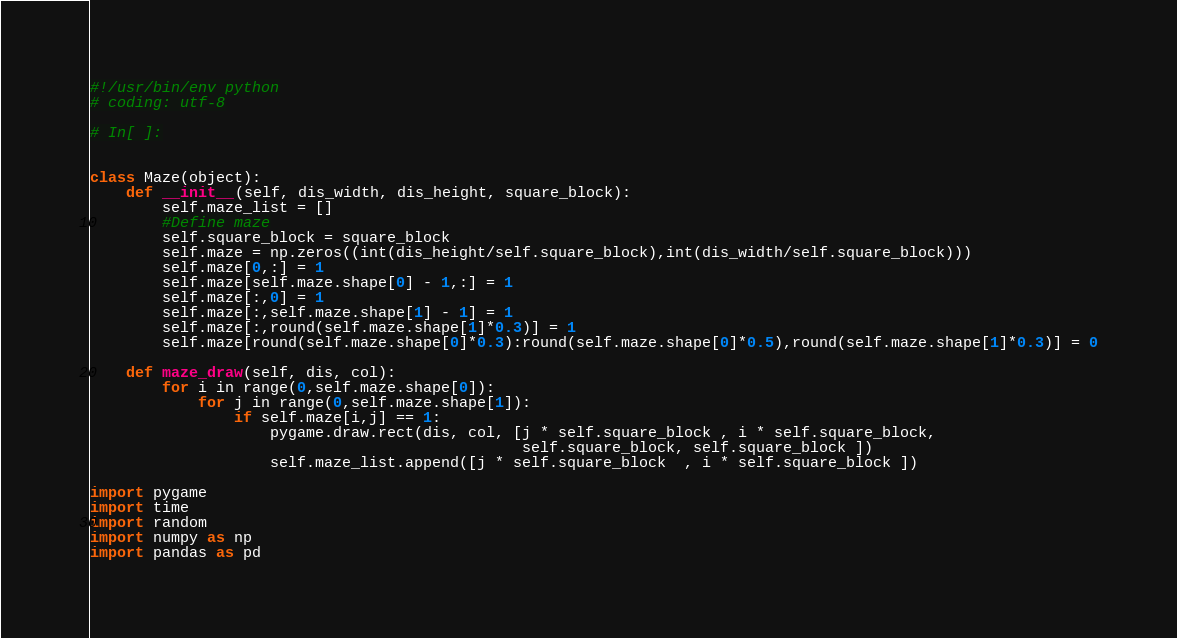<code> <loc_0><loc_0><loc_500><loc_500><_Python_>#!/usr/bin/env python
# coding: utf-8

# In[ ]:


class Maze(object):
    def __init__(self, dis_width, dis_height, square_block):
        self.maze_list = []
        #Define maze
        self.square_block = square_block
        self.maze = np.zeros((int(dis_height/self.square_block),int(dis_width/self.square_block)))
        self.maze[0,:] = 1
        self.maze[self.maze.shape[0] - 1,:] = 1
        self.maze[:,0] = 1
        self.maze[:,self.maze.shape[1] - 1] = 1
        self.maze[:,round(self.maze.shape[1]*0.3)] = 1
        self.maze[round(self.maze.shape[0]*0.3):round(self.maze.shape[0]*0.5),round(self.maze.shape[1]*0.3)] = 0
    
    def maze_draw(self, dis, col):
        for i in range(0,self.maze.shape[0]):
            for j in range(0,self.maze.shape[1]):
                if self.maze[i,j] == 1:
                    pygame.draw.rect(dis, col, [j * self.square_block , i * self.square_block,
                                                self.square_block, self.square_block ])     
                    self.maze_list.append([j * self.square_block  , i * self.square_block ])

import pygame
import time
import random
import numpy as np
import pandas as pd

</code> 